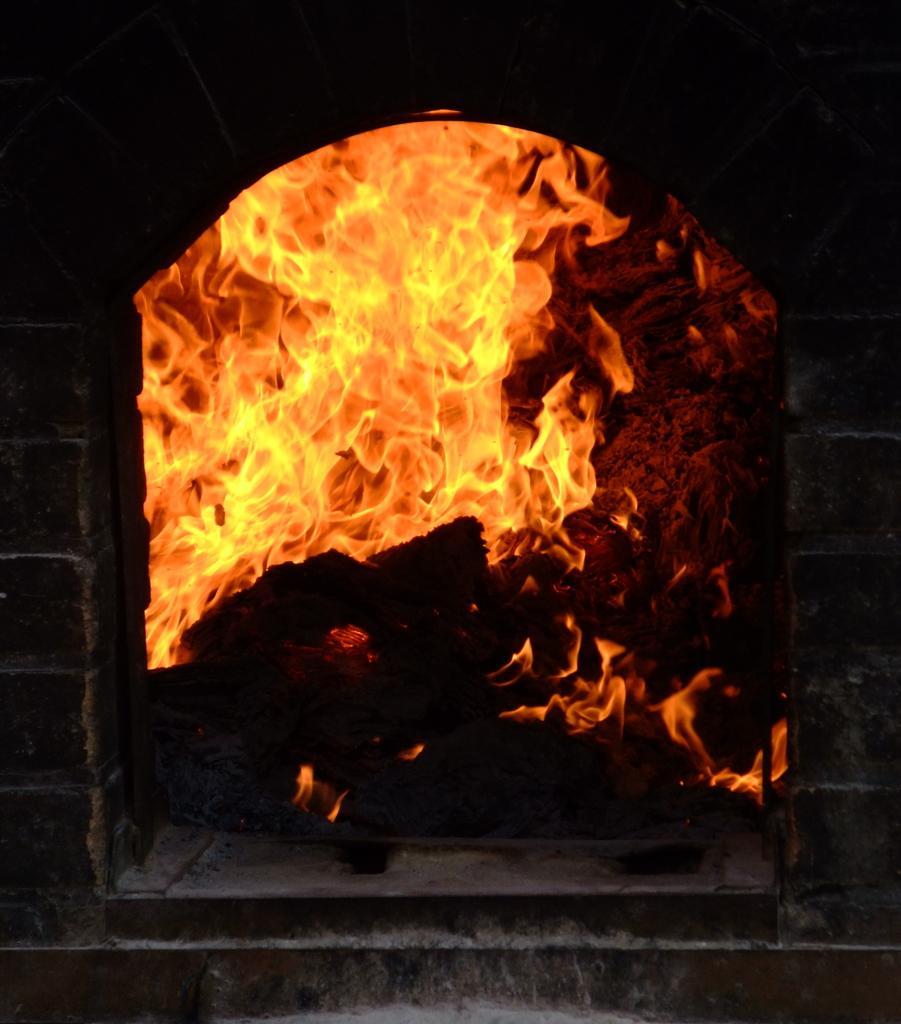Describe this image in one or two sentences. In this picture we can see flame. 